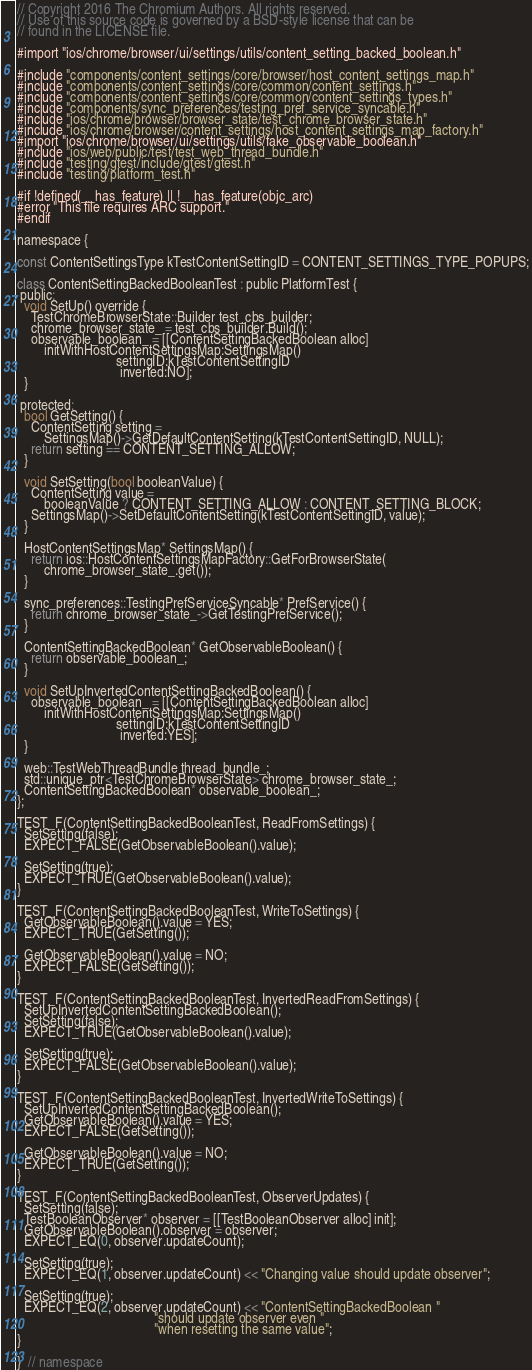Convert code to text. <code><loc_0><loc_0><loc_500><loc_500><_ObjectiveC_>// Copyright 2016 The Chromium Authors. All rights reserved.
// Use of this source code is governed by a BSD-style license that can be
// found in the LICENSE file.

#import "ios/chrome/browser/ui/settings/utils/content_setting_backed_boolean.h"

#include "components/content_settings/core/browser/host_content_settings_map.h"
#include "components/content_settings/core/common/content_settings.h"
#include "components/content_settings/core/common/content_settings_types.h"
#include "components/sync_preferences/testing_pref_service_syncable.h"
#include "ios/chrome/browser/browser_state/test_chrome_browser_state.h"
#include "ios/chrome/browser/content_settings/host_content_settings_map_factory.h"
#import "ios/chrome/browser/ui/settings/utils/fake_observable_boolean.h"
#include "ios/web/public/test/test_web_thread_bundle.h"
#include "testing/gtest/include/gtest/gtest.h"
#include "testing/platform_test.h"

#if !defined(__has_feature) || !__has_feature(objc_arc)
#error "This file requires ARC support."
#endif

namespace {

const ContentSettingsType kTestContentSettingID = CONTENT_SETTINGS_TYPE_POPUPS;

class ContentSettingBackedBooleanTest : public PlatformTest {
 public:
  void SetUp() override {
    TestChromeBrowserState::Builder test_cbs_builder;
    chrome_browser_state_ = test_cbs_builder.Build();
    observable_boolean_ = [[ContentSettingBackedBoolean alloc]
        initWithHostContentSettingsMap:SettingsMap()
                             settingID:kTestContentSettingID
                              inverted:NO];
  }

 protected:
  bool GetSetting() {
    ContentSetting setting =
        SettingsMap()->GetDefaultContentSetting(kTestContentSettingID, NULL);
    return setting == CONTENT_SETTING_ALLOW;
  }

  void SetSetting(bool booleanValue) {
    ContentSetting value =
        booleanValue ? CONTENT_SETTING_ALLOW : CONTENT_SETTING_BLOCK;
    SettingsMap()->SetDefaultContentSetting(kTestContentSettingID, value);
  }

  HostContentSettingsMap* SettingsMap() {
    return ios::HostContentSettingsMapFactory::GetForBrowserState(
        chrome_browser_state_.get());
  }

  sync_preferences::TestingPrefServiceSyncable* PrefService() {
    return chrome_browser_state_->GetTestingPrefService();
  }

  ContentSettingBackedBoolean* GetObservableBoolean() {
    return observable_boolean_;
  }

  void SetUpInvertedContentSettingBackedBoolean() {
    observable_boolean_ = [[ContentSettingBackedBoolean alloc]
        initWithHostContentSettingsMap:SettingsMap()
                             settingID:kTestContentSettingID
                              inverted:YES];
  }

  web::TestWebThreadBundle thread_bundle_;
  std::unique_ptr<TestChromeBrowserState> chrome_browser_state_;
  ContentSettingBackedBoolean* observable_boolean_;
};

TEST_F(ContentSettingBackedBooleanTest, ReadFromSettings) {
  SetSetting(false);
  EXPECT_FALSE(GetObservableBoolean().value);

  SetSetting(true);
  EXPECT_TRUE(GetObservableBoolean().value);
}

TEST_F(ContentSettingBackedBooleanTest, WriteToSettings) {
  GetObservableBoolean().value = YES;
  EXPECT_TRUE(GetSetting());

  GetObservableBoolean().value = NO;
  EXPECT_FALSE(GetSetting());
}

TEST_F(ContentSettingBackedBooleanTest, InvertedReadFromSettings) {
  SetUpInvertedContentSettingBackedBoolean();
  SetSetting(false);
  EXPECT_TRUE(GetObservableBoolean().value);

  SetSetting(true);
  EXPECT_FALSE(GetObservableBoolean().value);
}

TEST_F(ContentSettingBackedBooleanTest, InvertedWriteToSettings) {
  SetUpInvertedContentSettingBackedBoolean();
  GetObservableBoolean().value = YES;
  EXPECT_FALSE(GetSetting());

  GetObservableBoolean().value = NO;
  EXPECT_TRUE(GetSetting());
}

TEST_F(ContentSettingBackedBooleanTest, ObserverUpdates) {
  SetSetting(false);
  TestBooleanObserver* observer = [[TestBooleanObserver alloc] init];
  GetObservableBoolean().observer = observer;
  EXPECT_EQ(0, observer.updateCount);

  SetSetting(true);
  EXPECT_EQ(1, observer.updateCount) << "Changing value should update observer";

  SetSetting(true);
  EXPECT_EQ(2, observer.updateCount) << "ContentSettingBackedBoolean "
                                        "should update observer even "
                                        "when resetting the same value";
}

}  // namespace
</code> 